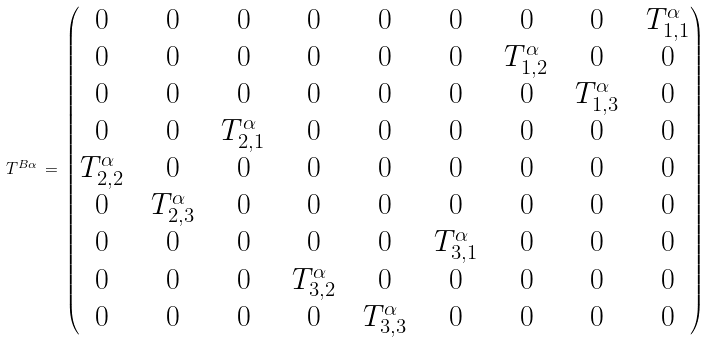Convert formula to latex. <formula><loc_0><loc_0><loc_500><loc_500>T ^ { B \alpha } \, = \, \left ( \begin{matrix} 0 \, & \, 0 \, & \, 0 \, & \, 0 \, & \, 0 \, & \, 0 \, & \, 0 \, & \, 0 \, & \, T ^ { \alpha } _ { 1 , 1 } \\ 0 \, & \, 0 \, & \, 0 \, & \, 0 \, & \, 0 \, & \, 0 \, & \, T ^ { \alpha } _ { 1 , 2 } \, & \, 0 \, & \, 0 \\ 0 \, & \, 0 \, & \, 0 \, & \, 0 \, & \, 0 \, & \, 0 \, & \, 0 \, & \, T ^ { \alpha } _ { 1 , 3 } \, & \, 0 \\ 0 \, & \, 0 \, & \, T ^ { \alpha } _ { 2 , 1 } \, & \, 0 \, & \, 0 \, & \, 0 \, & \, 0 \, & \, 0 \, & \, 0 \\ T ^ { \alpha } _ { 2 , 2 } \, & \, 0 \, & \, 0 \, & \, 0 \, & \, 0 \, & \, 0 \, & \, 0 \, & \, 0 \, & \, 0 \\ 0 \, & \, T ^ { \alpha } _ { 2 , 3 } \, & \, 0 \, & \, 0 \, & \, 0 \, & \, 0 \, & \, 0 \, & \, 0 \, & \, 0 \\ 0 \, & \, 0 \, & \, 0 \, & \, 0 \, & \, 0 \, & \, T ^ { \alpha } _ { 3 , 1 } \, & \, 0 \, & \, 0 \, & \, 0 \\ 0 \, & \, 0 \, & \, 0 \, & \, T ^ { \alpha } _ { 3 , 2 } \, & \, 0 \, & \, 0 \, & \, 0 \, & \, 0 \, & \, 0 \\ 0 \, & \, 0 \, & \, 0 \, & \, 0 \, & \, T ^ { \alpha } _ { 3 , 3 } \, & \, 0 \, & \, 0 \, & \, 0 \, & \, 0 \end{matrix} \right )</formula> 